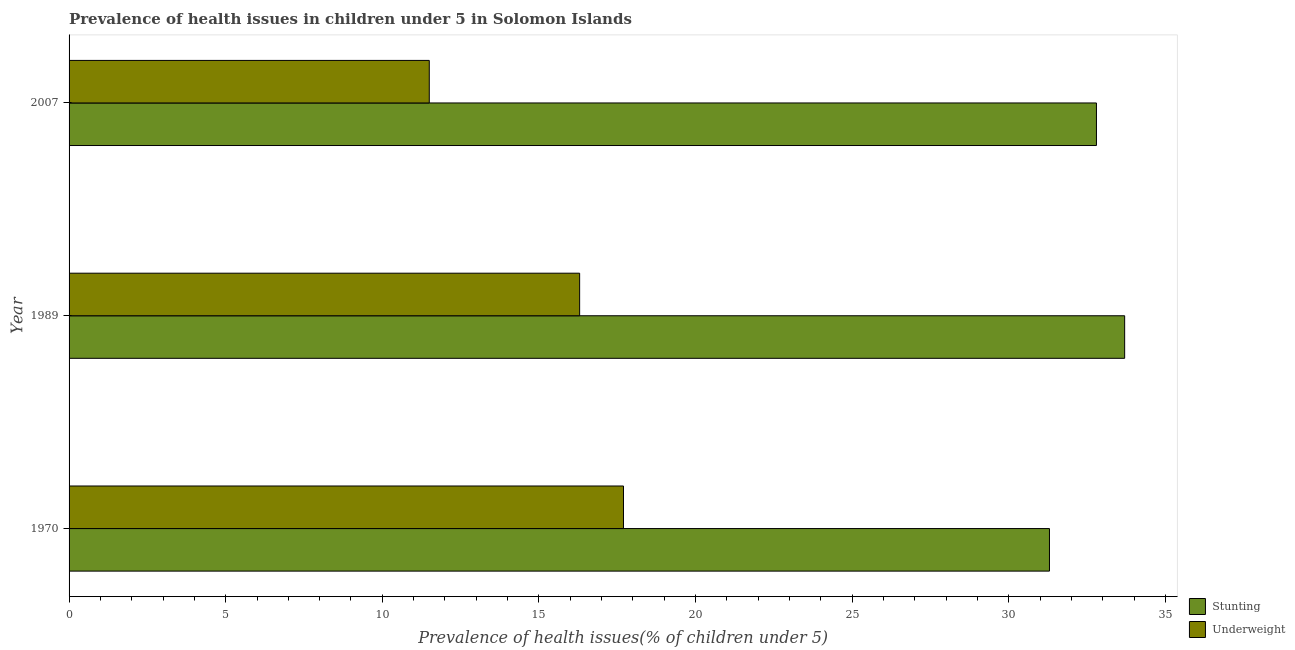How many different coloured bars are there?
Your response must be concise. 2. How many groups of bars are there?
Ensure brevity in your answer.  3. Are the number of bars per tick equal to the number of legend labels?
Ensure brevity in your answer.  Yes. How many bars are there on the 2nd tick from the bottom?
Offer a very short reply. 2. In how many cases, is the number of bars for a given year not equal to the number of legend labels?
Give a very brief answer. 0. What is the percentage of underweight children in 1970?
Offer a very short reply. 17.7. Across all years, what is the maximum percentage of underweight children?
Your answer should be compact. 17.7. Across all years, what is the minimum percentage of underweight children?
Offer a very short reply. 11.5. What is the total percentage of underweight children in the graph?
Your response must be concise. 45.5. What is the difference between the percentage of underweight children in 1970 and that in 2007?
Ensure brevity in your answer.  6.2. What is the difference between the percentage of underweight children in 1989 and the percentage of stunted children in 1970?
Provide a short and direct response. -15. What is the average percentage of underweight children per year?
Give a very brief answer. 15.17. What is the ratio of the percentage of stunted children in 1970 to that in 1989?
Offer a terse response. 0.93. Is the difference between the percentage of stunted children in 1989 and 2007 greater than the difference between the percentage of underweight children in 1989 and 2007?
Provide a succinct answer. No. What is the difference between the highest and the lowest percentage of stunted children?
Your response must be concise. 2.4. Is the sum of the percentage of stunted children in 1970 and 1989 greater than the maximum percentage of underweight children across all years?
Offer a terse response. Yes. What does the 2nd bar from the top in 1989 represents?
Your answer should be compact. Stunting. What does the 2nd bar from the bottom in 1989 represents?
Offer a very short reply. Underweight. How many years are there in the graph?
Your answer should be very brief. 3. What is the difference between two consecutive major ticks on the X-axis?
Provide a succinct answer. 5. Does the graph contain any zero values?
Keep it short and to the point. No. Does the graph contain grids?
Make the answer very short. No. How many legend labels are there?
Provide a short and direct response. 2. How are the legend labels stacked?
Provide a succinct answer. Vertical. What is the title of the graph?
Ensure brevity in your answer.  Prevalence of health issues in children under 5 in Solomon Islands. Does "Netherlands" appear as one of the legend labels in the graph?
Provide a short and direct response. No. What is the label or title of the X-axis?
Your answer should be very brief. Prevalence of health issues(% of children under 5). What is the Prevalence of health issues(% of children under 5) in Stunting in 1970?
Provide a short and direct response. 31.3. What is the Prevalence of health issues(% of children under 5) in Underweight in 1970?
Your answer should be compact. 17.7. What is the Prevalence of health issues(% of children under 5) in Stunting in 1989?
Your response must be concise. 33.7. What is the Prevalence of health issues(% of children under 5) of Underweight in 1989?
Provide a succinct answer. 16.3. What is the Prevalence of health issues(% of children under 5) of Stunting in 2007?
Make the answer very short. 32.8. Across all years, what is the maximum Prevalence of health issues(% of children under 5) of Stunting?
Provide a short and direct response. 33.7. Across all years, what is the maximum Prevalence of health issues(% of children under 5) of Underweight?
Your answer should be compact. 17.7. Across all years, what is the minimum Prevalence of health issues(% of children under 5) of Stunting?
Your response must be concise. 31.3. Across all years, what is the minimum Prevalence of health issues(% of children under 5) of Underweight?
Provide a short and direct response. 11.5. What is the total Prevalence of health issues(% of children under 5) of Stunting in the graph?
Provide a short and direct response. 97.8. What is the total Prevalence of health issues(% of children under 5) of Underweight in the graph?
Provide a succinct answer. 45.5. What is the difference between the Prevalence of health issues(% of children under 5) of Underweight in 1970 and that in 1989?
Your answer should be very brief. 1.4. What is the difference between the Prevalence of health issues(% of children under 5) of Underweight in 1970 and that in 2007?
Your answer should be very brief. 6.2. What is the difference between the Prevalence of health issues(% of children under 5) of Stunting in 1989 and that in 2007?
Offer a terse response. 0.9. What is the difference between the Prevalence of health issues(% of children under 5) of Stunting in 1970 and the Prevalence of health issues(% of children under 5) of Underweight in 1989?
Your response must be concise. 15. What is the difference between the Prevalence of health issues(% of children under 5) in Stunting in 1970 and the Prevalence of health issues(% of children under 5) in Underweight in 2007?
Make the answer very short. 19.8. What is the average Prevalence of health issues(% of children under 5) in Stunting per year?
Provide a succinct answer. 32.6. What is the average Prevalence of health issues(% of children under 5) of Underweight per year?
Make the answer very short. 15.17. In the year 2007, what is the difference between the Prevalence of health issues(% of children under 5) in Stunting and Prevalence of health issues(% of children under 5) in Underweight?
Give a very brief answer. 21.3. What is the ratio of the Prevalence of health issues(% of children under 5) of Stunting in 1970 to that in 1989?
Offer a terse response. 0.93. What is the ratio of the Prevalence of health issues(% of children under 5) in Underweight in 1970 to that in 1989?
Provide a succinct answer. 1.09. What is the ratio of the Prevalence of health issues(% of children under 5) of Stunting in 1970 to that in 2007?
Provide a succinct answer. 0.95. What is the ratio of the Prevalence of health issues(% of children under 5) in Underweight in 1970 to that in 2007?
Offer a very short reply. 1.54. What is the ratio of the Prevalence of health issues(% of children under 5) in Stunting in 1989 to that in 2007?
Offer a very short reply. 1.03. What is the ratio of the Prevalence of health issues(% of children under 5) in Underweight in 1989 to that in 2007?
Ensure brevity in your answer.  1.42. What is the difference between the highest and the second highest Prevalence of health issues(% of children under 5) of Stunting?
Provide a succinct answer. 0.9. What is the difference between the highest and the second highest Prevalence of health issues(% of children under 5) in Underweight?
Provide a short and direct response. 1.4. 